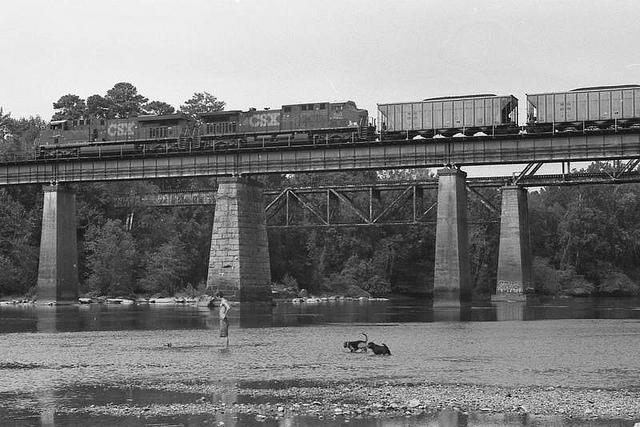Why is the train on a bridge? crossing river 